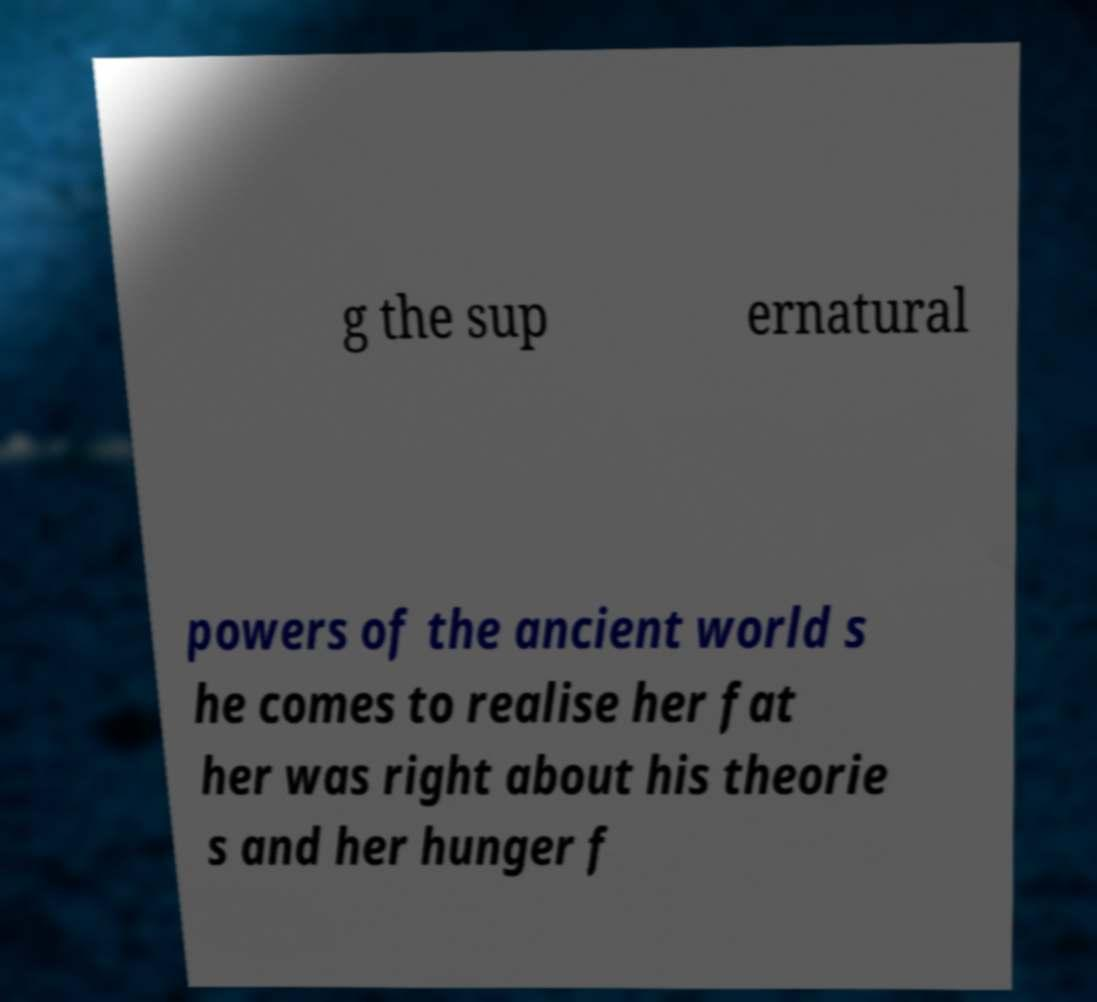Can you read and provide the text displayed in the image?This photo seems to have some interesting text. Can you extract and type it out for me? g the sup ernatural powers of the ancient world s he comes to realise her fat her was right about his theorie s and her hunger f 